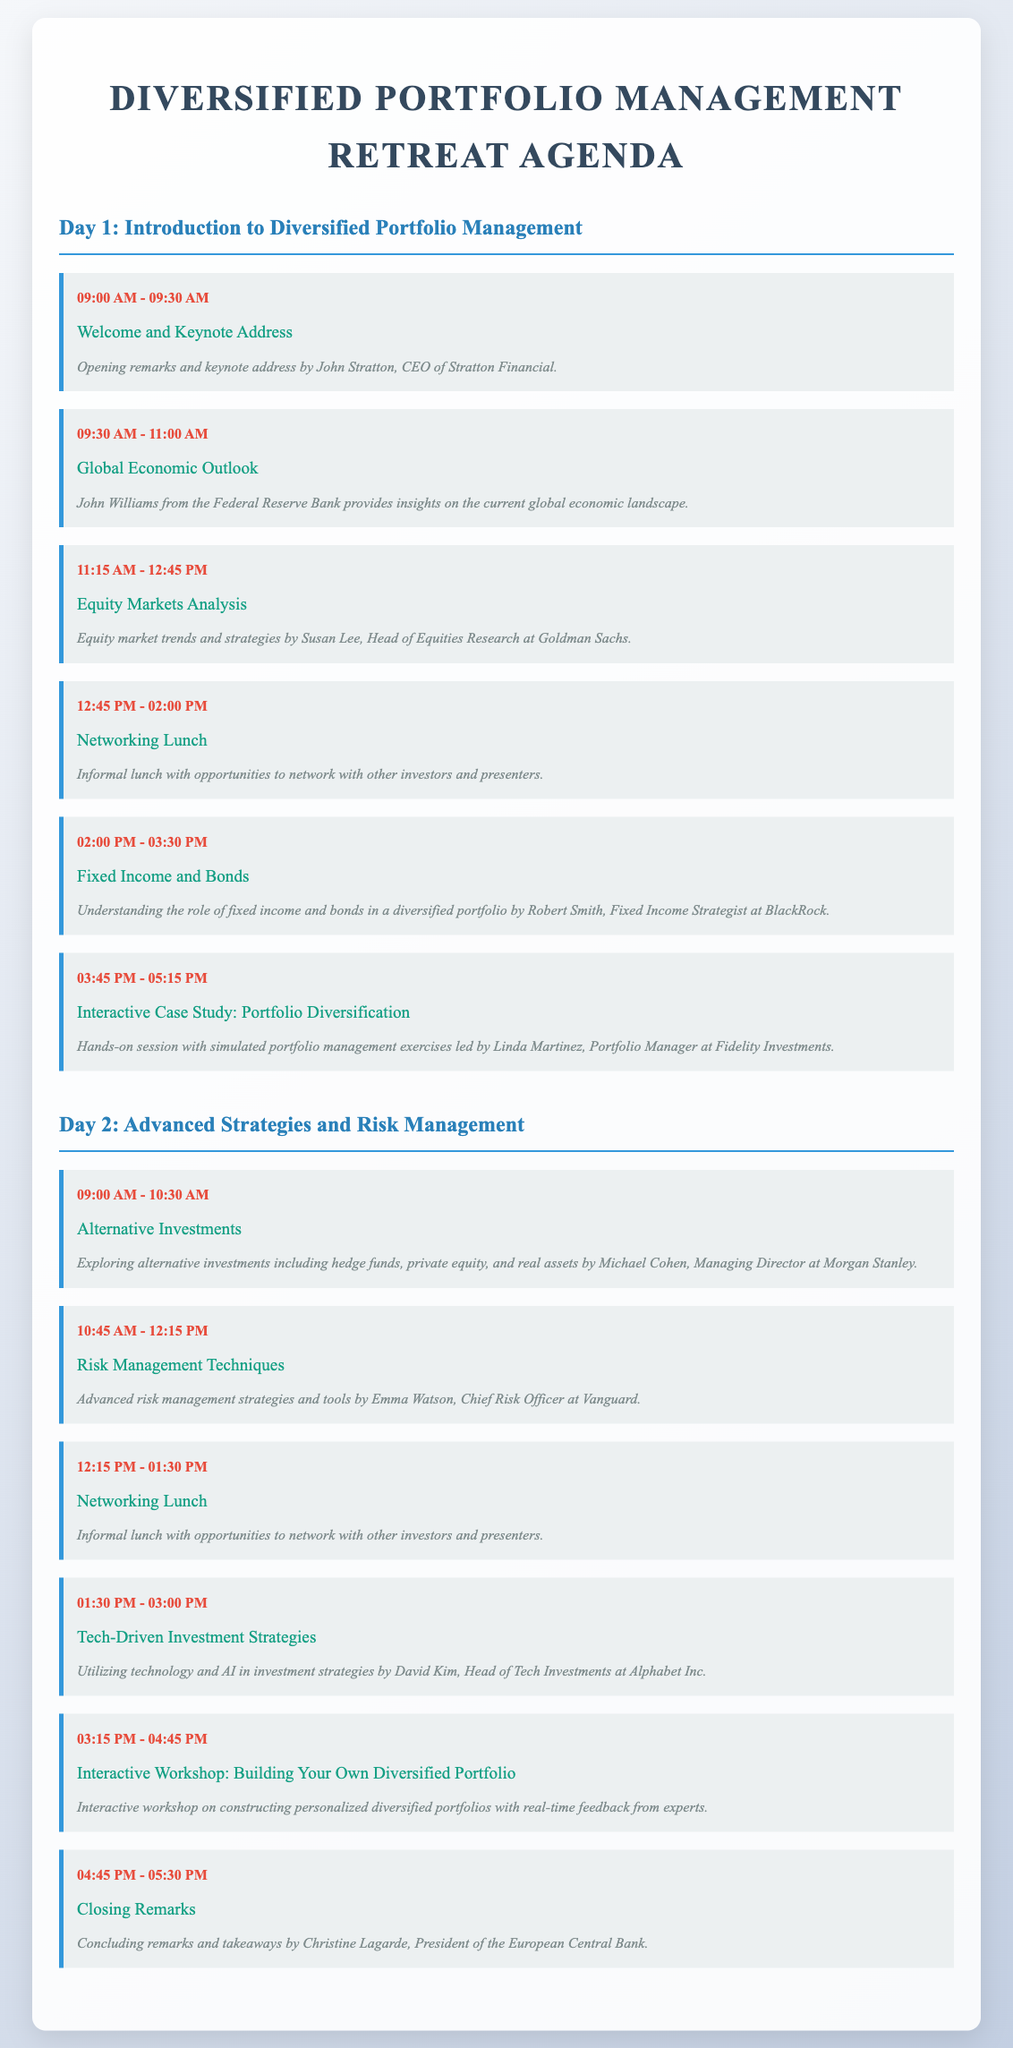What time does the welcome address start? The welcome address is scheduled to start at 09:00 AM.
Answer: 09:00 AM Who is the speaker for the session on Global Economic Outlook? The speaker for the Global Economic Outlook session is John Williams.
Answer: John Williams What is the title of the session at 03:45 PM on Day 1? The title of the session at 03:45 PM on Day 1 is "Interactive Case Study: Portfolio Diversification."
Answer: Interactive Case Study: Portfolio Diversification How many sessions are scheduled for Day 2? There are six sessions scheduled for Day 2.
Answer: Six What is the focus of the interactive workshop on Day 2? The focus of the interactive workshop on Day 2 is on constructing personalized diversified portfolios.
Answer: Constructing personalized diversified portfolios Who provides closing remarks at the end of the retreat? The closing remarks are provided by Christine Lagarde.
Answer: Christine Lagarde What session is right before the networking lunch on Day 2? The session right before the networking lunch on Day 2 is "Risk Management Techniques."
Answer: Risk Management Techniques 